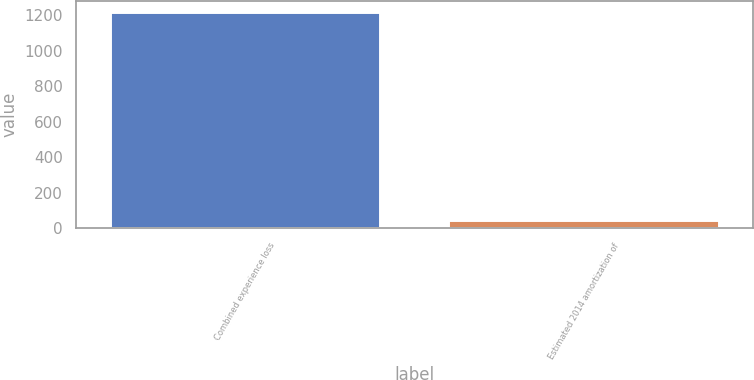Convert chart. <chart><loc_0><loc_0><loc_500><loc_500><bar_chart><fcel>Combined experience loss<fcel>Estimated 2014 amortization of<nl><fcel>1219<fcel>44<nl></chart> 